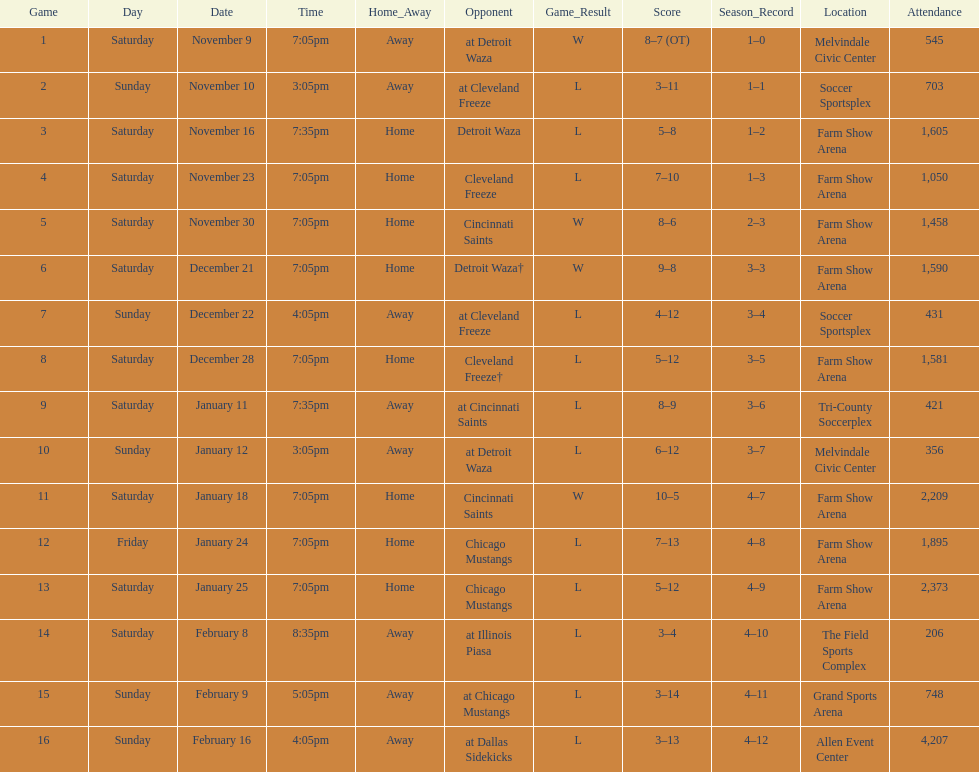Which opponent is listed after cleveland freeze in the table? Detroit Waza. Can you parse all the data within this table? {'header': ['Game', 'Day', 'Date', 'Time', 'Home_Away', 'Opponent', 'Game_Result', 'Score', 'Season_Record', 'Location', 'Attendance'], 'rows': [['1', 'Saturday', 'November 9', '7:05pm', 'Away', 'at Detroit Waza', 'W', '8–7 (OT)', '1–0', 'Melvindale Civic Center', '545'], ['2', 'Sunday', 'November 10', '3:05pm', 'Away', 'at Cleveland Freeze', 'L', '3–11', '1–1', 'Soccer Sportsplex', '703'], ['3', 'Saturday', 'November 16', '7:35pm', 'Home', 'Detroit Waza', 'L', '5–8', '1–2', 'Farm Show Arena', '1,605'], ['4', 'Saturday', 'November 23', '7:05pm', 'Home', 'Cleveland Freeze', 'L', '7–10', '1–3', 'Farm Show Arena', '1,050'], ['5', 'Saturday', 'November 30', '7:05pm', 'Home', 'Cincinnati Saints', 'W', '8–6', '2–3', 'Farm Show Arena', '1,458'], ['6', 'Saturday', 'December 21', '7:05pm', 'Home', 'Detroit Waza†', 'W', '9–8', '3–3', 'Farm Show Arena', '1,590'], ['7', 'Sunday', 'December 22', '4:05pm', 'Away', 'at Cleveland Freeze', 'L', '4–12', '3–4', 'Soccer Sportsplex', '431'], ['8', 'Saturday', 'December 28', '7:05pm', 'Home', 'Cleveland Freeze†', 'L', '5–12', '3–5', 'Farm Show Arena', '1,581'], ['9', 'Saturday', 'January 11', '7:35pm', 'Away', 'at Cincinnati Saints', 'L', '8–9', '3–6', 'Tri-County Soccerplex', '421'], ['10', 'Sunday', 'January 12', '3:05pm', 'Away', 'at Detroit Waza', 'L', '6–12', '3–7', 'Melvindale Civic Center', '356'], ['11', 'Saturday', 'January 18', '7:05pm', 'Home', 'Cincinnati Saints', 'W', '10–5', '4–7', 'Farm Show Arena', '2,209'], ['12', 'Friday', 'January 24', '7:05pm', 'Home', 'Chicago Mustangs', 'L', '7–13', '4–8', 'Farm Show Arena', '1,895'], ['13', 'Saturday', 'January 25', '7:05pm', 'Home', 'Chicago Mustangs', 'L', '5–12', '4–9', 'Farm Show Arena', '2,373'], ['14', 'Saturday', 'February 8', '8:35pm', 'Away', 'at Illinois Piasa', 'L', '3–4', '4–10', 'The Field Sports Complex', '206'], ['15', 'Sunday', 'February 9', '5:05pm', 'Away', 'at Chicago Mustangs', 'L', '3–14', '4–11', 'Grand Sports Arena', '748'], ['16', 'Sunday', 'February 16', '4:05pm', 'Away', 'at Dallas Sidekicks', 'L', '3–13', '4–12', 'Allen Event Center', '4,207']]} 